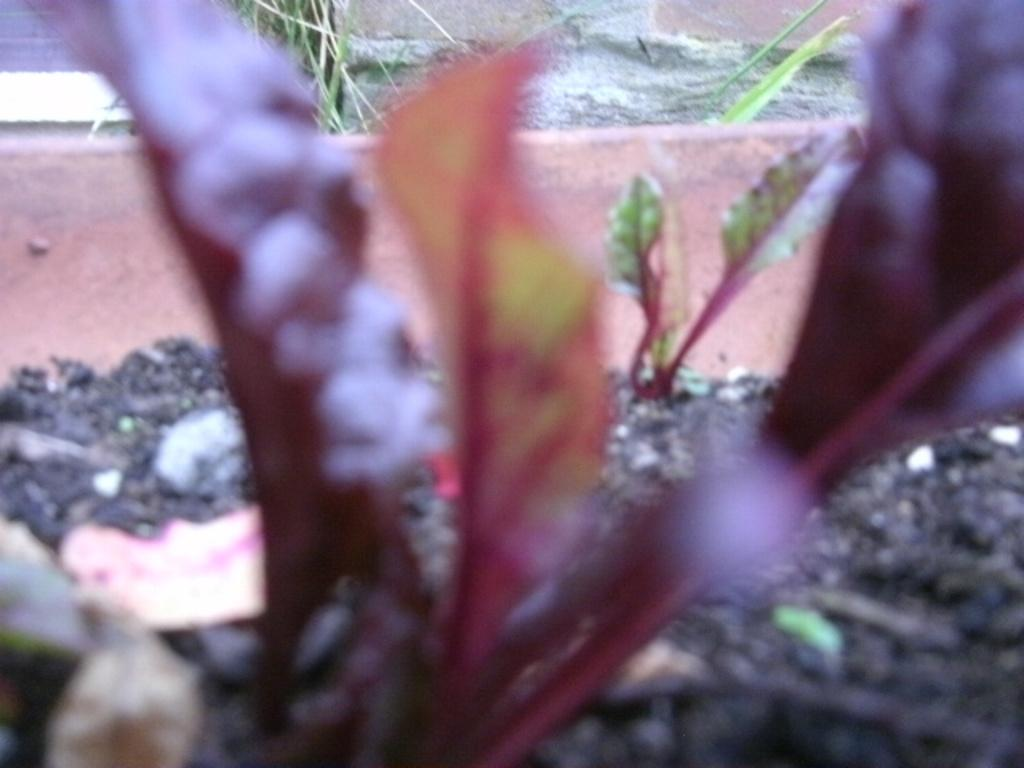What type of living organisms can be seen in the image? Plants can be seen in the image. What can be seen in the background of the image? There is black color mud, a wall, and grass in the background of the image. How would you describe the overall quality of the image? The image is blurry. What type of stitch is being used by the minister in the image? There is no minister or stitching present in the image. What form does the grass take in the image? The grass in the image appears as natural vegetation and does not take a specific form. 